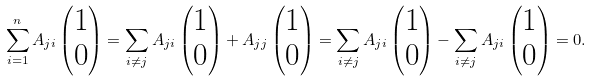<formula> <loc_0><loc_0><loc_500><loc_500>\sum _ { i = 1 } ^ { n } A _ { j i } \begin{pmatrix} 1 \\ 0 \end{pmatrix} = \sum _ { i \neq j } A _ { j i } \begin{pmatrix} 1 \\ 0 \end{pmatrix} + A _ { j j } \begin{pmatrix} 1 \\ 0 \end{pmatrix} = \sum _ { i \neq j } A _ { j i } \begin{pmatrix} 1 \\ 0 \end{pmatrix} - \sum _ { i \neq j } A _ { j i } \begin{pmatrix} 1 \\ 0 \end{pmatrix} = 0 .</formula> 